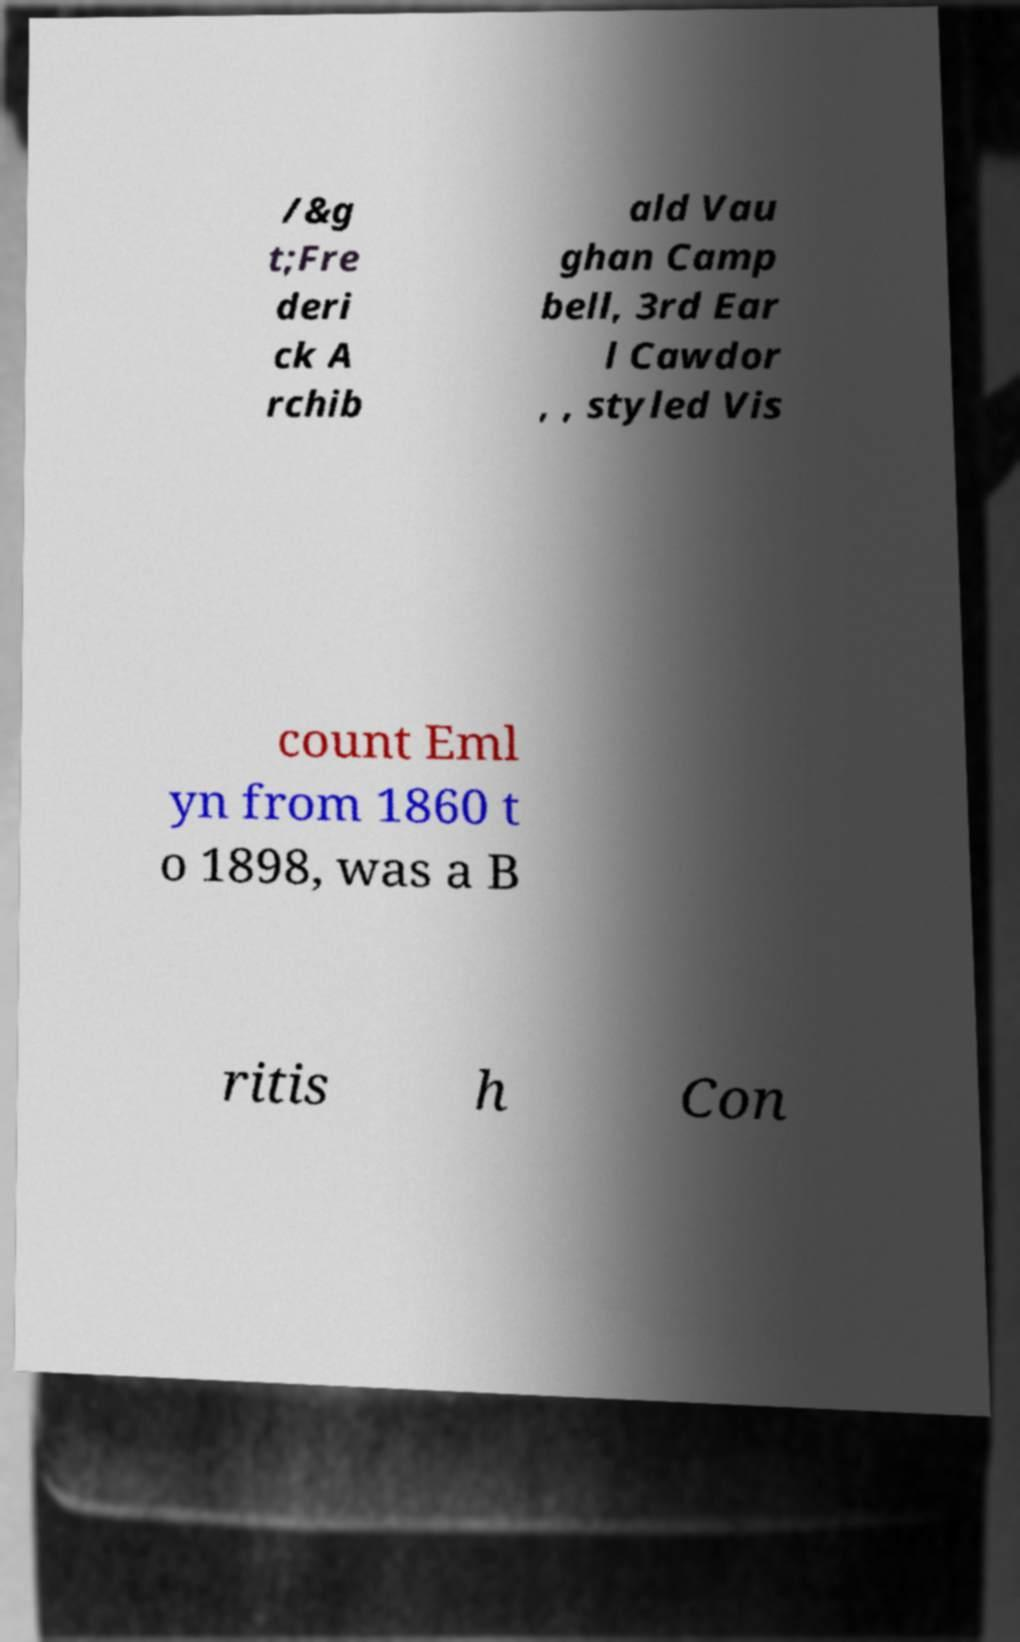Please identify and transcribe the text found in this image. /&g t;Fre deri ck A rchib ald Vau ghan Camp bell, 3rd Ear l Cawdor , , styled Vis count Eml yn from 1860 t o 1898, was a B ritis h Con 